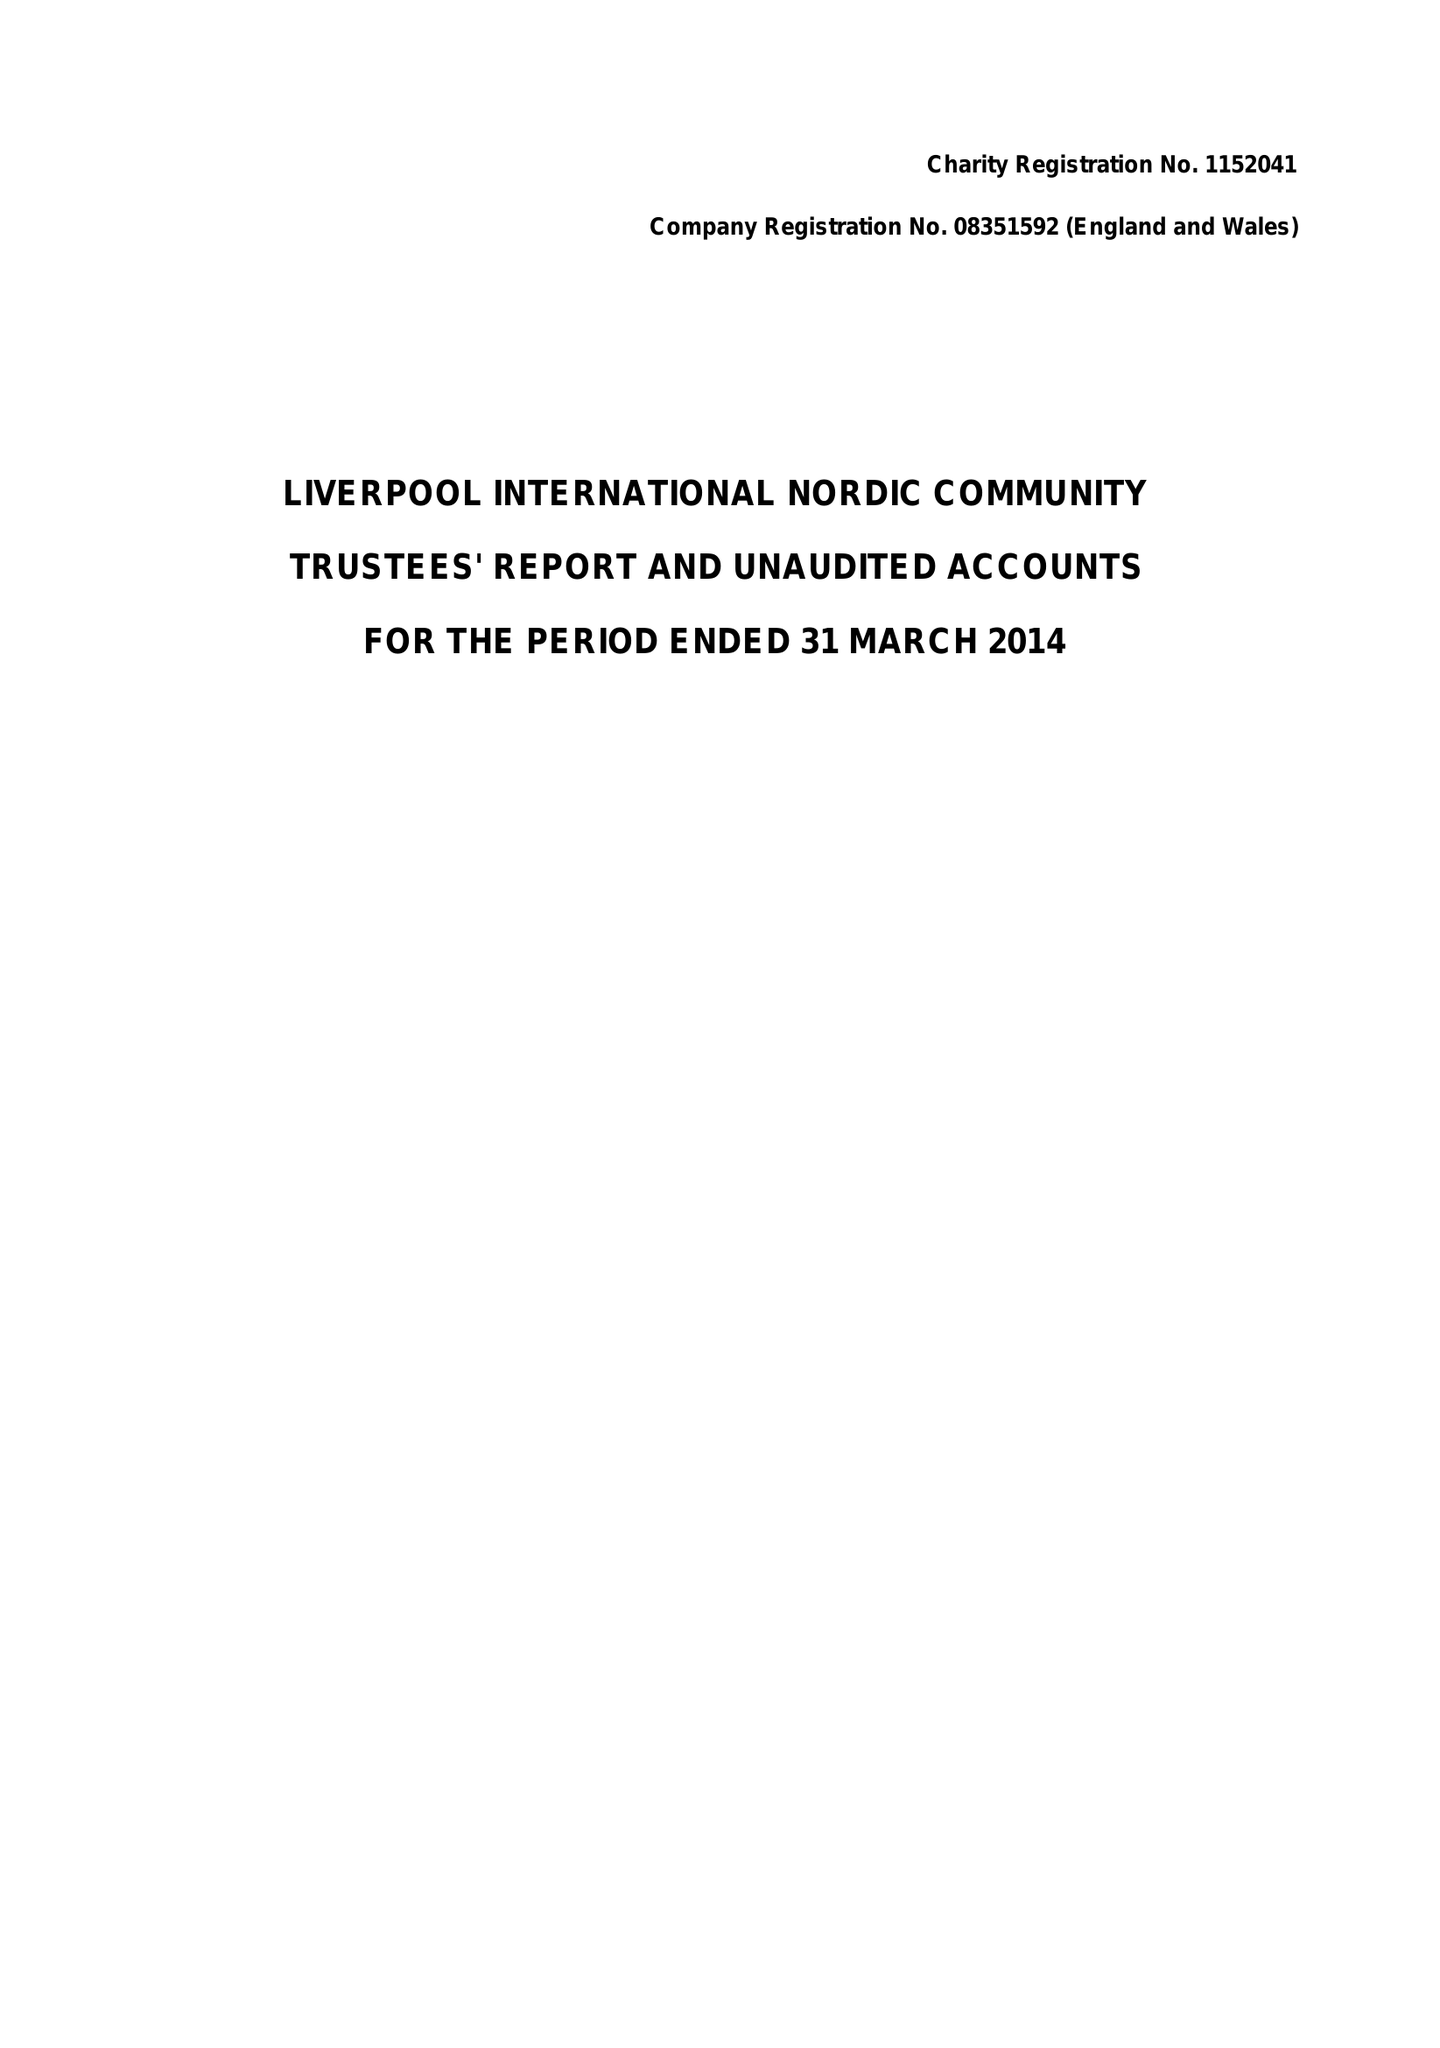What is the value for the report_date?
Answer the question using a single word or phrase. 2014-03-31 